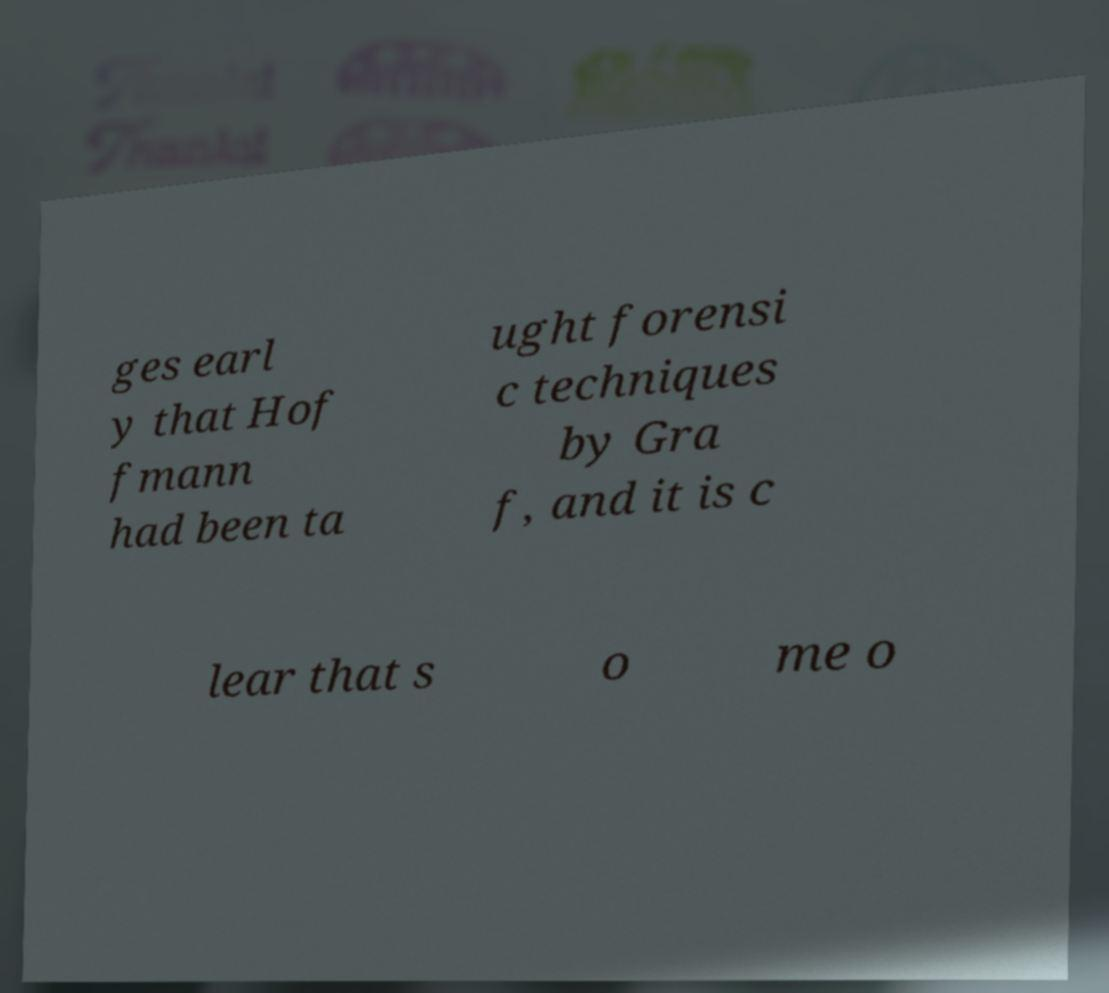Please read and relay the text visible in this image. What does it say? ges earl y that Hof fmann had been ta ught forensi c techniques by Gra f, and it is c lear that s o me o 